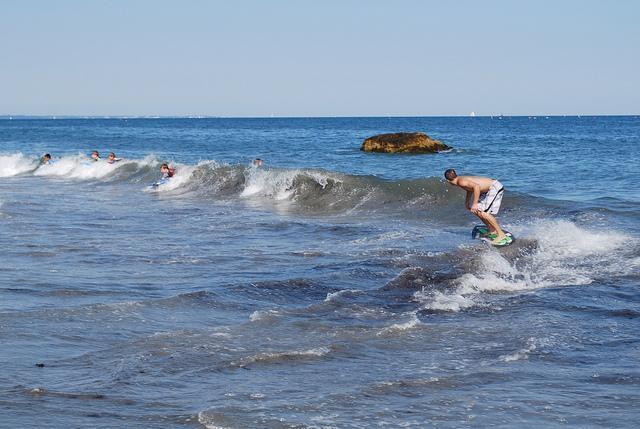How many people are in the water?
Give a very brief answer. 6. How many people are in the photo?
Give a very brief answer. 6. How many giraffes are shown?
Give a very brief answer. 0. 